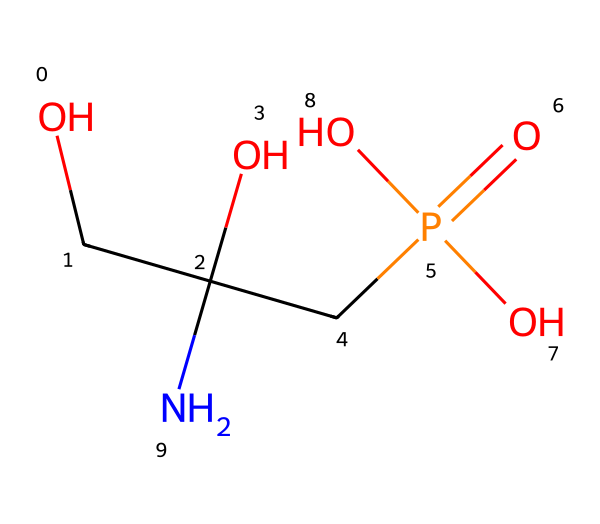What is the molecular formula of glyphosate? To find the molecular formula, count the number of each type of atom in the SMILES representation: C (Carbon) = 3, H (Hydrogen) = 8, N (Nitrogen) = 1, O (Oxygen) = 4, and P (Phosphorus) = 1. Therefore, the molecular formula is C3H8N1O4P1.
Answer: C3H8NO4P How many carbon atoms are present in glyphosate? In the SMILES, we identify carbon atoms directly: there are three carbon atoms represented by the 'C' characters in the structure.
Answer: 3 What type of herbicide is glyphosate classified as? Glyphosate is a broad-spectrum systemic herbicide, meaning it effectively kills a wide range of plant species by inhibiting a specific biochemical pathway.
Answer: systemic Which functional group makes glyphosate an effective herbicide? The presence of the phosphonic acid group in glyphosate's structure is critical, as it interacts with the shikimic acid pathway in plants, preventing growth.
Answer: phosphonic acid What is the total number of heteroatoms in glyphosate? Counting the heteroatoms (atoms that are not carbon or hydrogen), we see there are 5 heteroatoms: 1 nitrogen, 4 oxygens, and 1 phosphorus. Thus, the total is 6.
Answer: 6 What role does the amine group in glyphosate play? The amine group in glyphosate is important for its solubility in water and overall biological activity by facilitating the interaction with enzymes involved in plant metabolism.
Answer: solubility What is the significance of the -CP(=O)(O)O fragment in glyphosate? The -CP(=O)(O)O fragment indicates the presence of a phosphorus atom bonded to oxygen and a hydroxyl group, which contributes to glyphosate's activity as a herbicide by inhibiting specific pathways in plants.
Answer: herbicide activity 